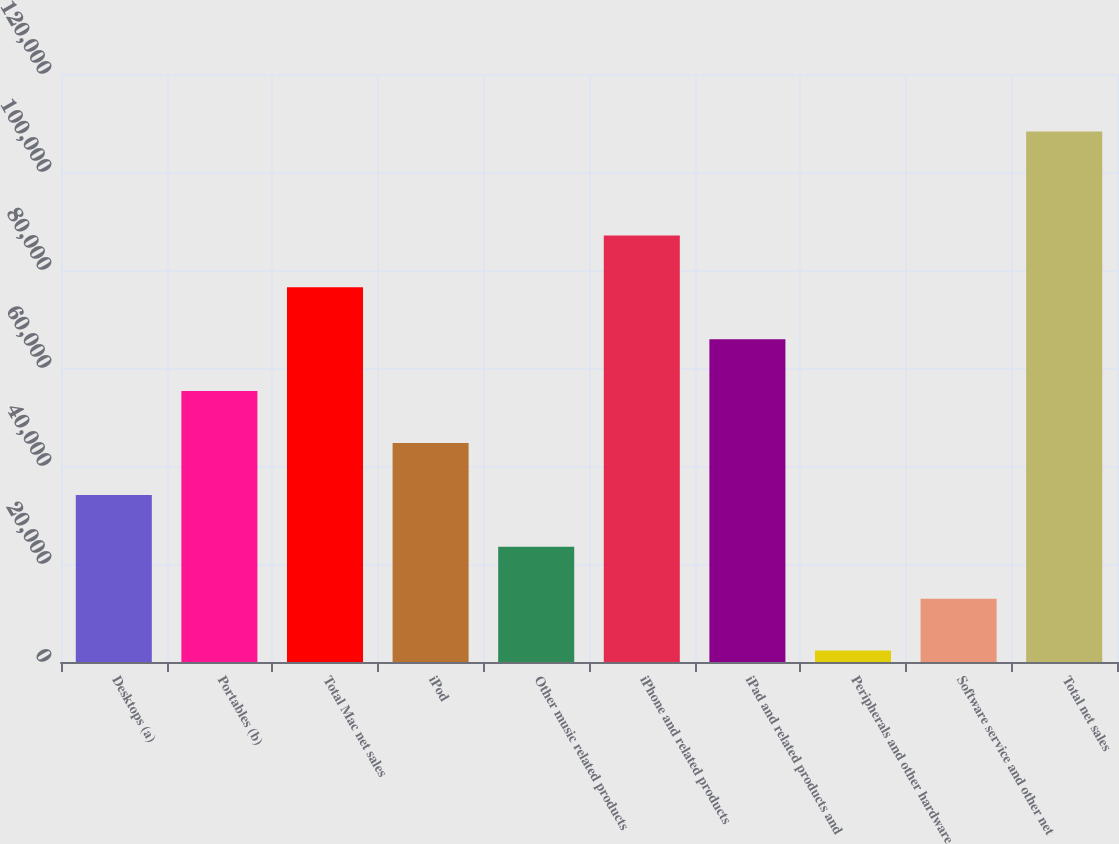Convert chart to OTSL. <chart><loc_0><loc_0><loc_500><loc_500><bar_chart><fcel>Desktops (a)<fcel>Portables (b)<fcel>Total Mac net sales<fcel>iPod<fcel>Other music related products<fcel>iPhone and related products<fcel>iPad and related products and<fcel>Peripherals and other hardware<fcel>Software service and other net<fcel>Total net sales<nl><fcel>34105.7<fcel>55289.5<fcel>76473.3<fcel>44697.6<fcel>23513.8<fcel>87065.2<fcel>65881.4<fcel>2330<fcel>12921.9<fcel>108249<nl></chart> 